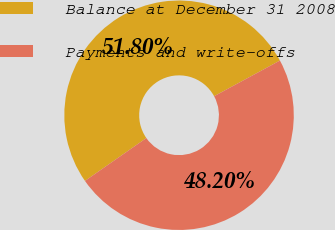<chart> <loc_0><loc_0><loc_500><loc_500><pie_chart><fcel>Balance at December 31 2008<fcel>Payments and write-offs<nl><fcel>51.8%<fcel>48.2%<nl></chart> 